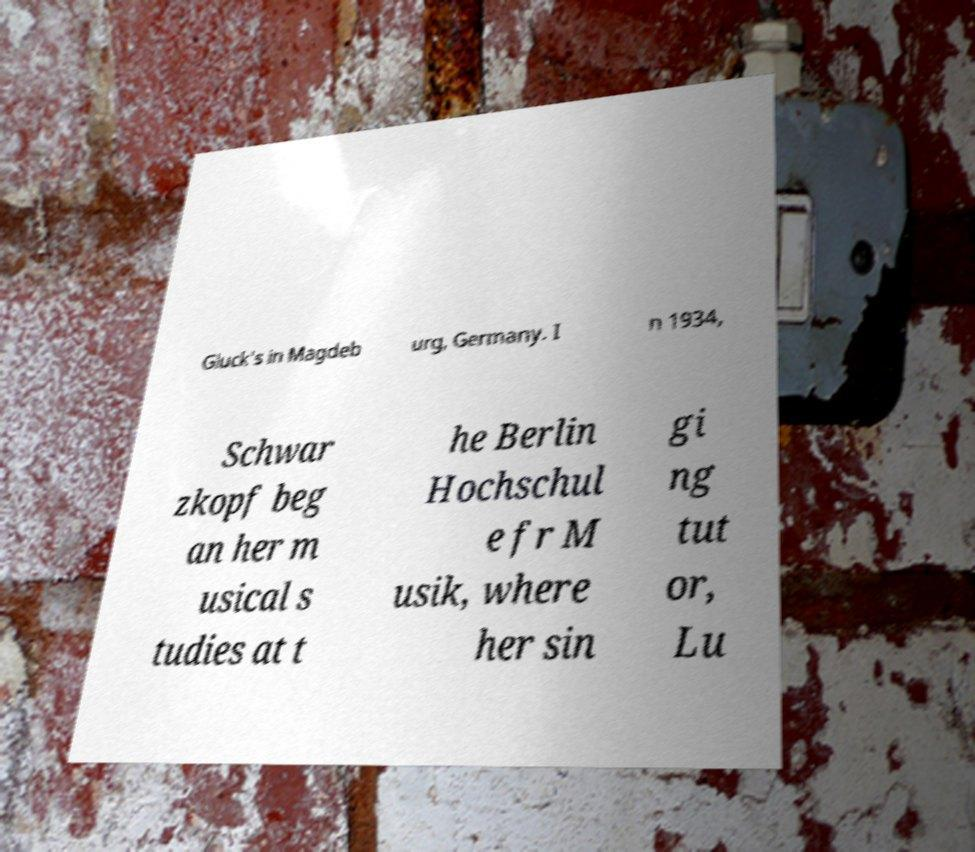Can you read and provide the text displayed in the image?This photo seems to have some interesting text. Can you extract and type it out for me? Gluck's in Magdeb urg, Germany. I n 1934, Schwar zkopf beg an her m usical s tudies at t he Berlin Hochschul e fr M usik, where her sin gi ng tut or, Lu 